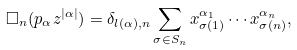<formula> <loc_0><loc_0><loc_500><loc_500>\Box _ { n } ( p _ { \alpha } z ^ { | \alpha | } ) = \delta _ { l ( \alpha ) , n } \sum _ { \sigma \in S _ { n } } x ^ { \alpha _ { 1 } } _ { \sigma ( 1 ) } \cdots x ^ { \alpha _ { n } } _ { \sigma ( n ) } ,</formula> 